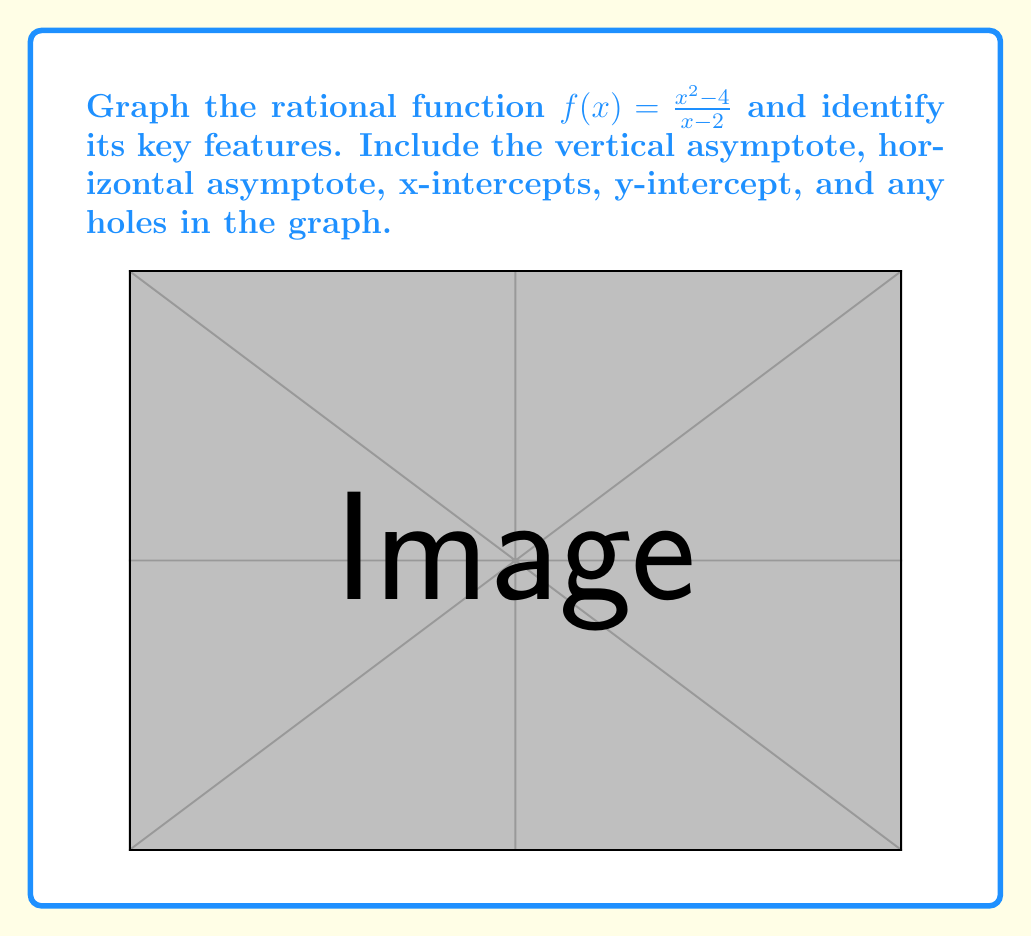Show me your answer to this math problem. Let's approach this step-by-step:

1) Vertical Asymptote:
   The vertical asymptote occurs when the denominator equals zero.
   $x - 2 = 0$
   $x = 2$

2) Horizontal Asymptote:
   To find the horizontal asymptote, we compare the degrees of the numerator and denominator.
   Numerator degree: 2
   Denominator degree: 1
   Since the numerator degree is greater, we divide:
   $$\lim_{x \to \infty} \frac{x^2 - 4}{x - 2} = \lim_{x \to \infty} (x + 2) = \infty$$
   The slant asymptote is $y = x + 2$

3) X-intercepts:
   Set $f(x) = 0$:
   $\frac{x^2 - 4}{x - 2} = 0$
   $x^2 - 4 = 0$
   $(x+2)(x-2) = 0$
   $x = -2$ or $x = 2$
   However, $x = 2$ is the vertical asymptote, so only $x = -2$ is an x-intercept.

4) Y-intercept:
   Set $x = 0$:
   $f(0) = \frac{0^2 - 4}{0 - 2} = \frac{-4}{-2} = -2$

5) Holes:
   A hole occurs when a factor cancels between numerator and denominator:
   $f(x) = \frac{x^2 - 4}{x - 2} = \frac{(x+2)(x-2)}{x - 2} = x + 2$ for $x \neq 2$
   At $x = 2$, there's a hole at $y = 2 + 2 = 4$

6) Graph:
   - Draw the vertical asymptote at $x = 2$
   - Draw the slant asymptote $y = x + 2$
   - Plot the x-intercept $(-2, 0)$
   - Plot the y-intercept $(0, -2)$
   - Mark the hole at $(2, 6)$
   - Sketch the curve approaching the asymptotes and passing through the plotted points
Answer: VA: $x=2$; HA: $y=x+2$; x-intercept: $(-2,0)$; y-intercept: $(0,-2)$; hole: $(2,6)$ 